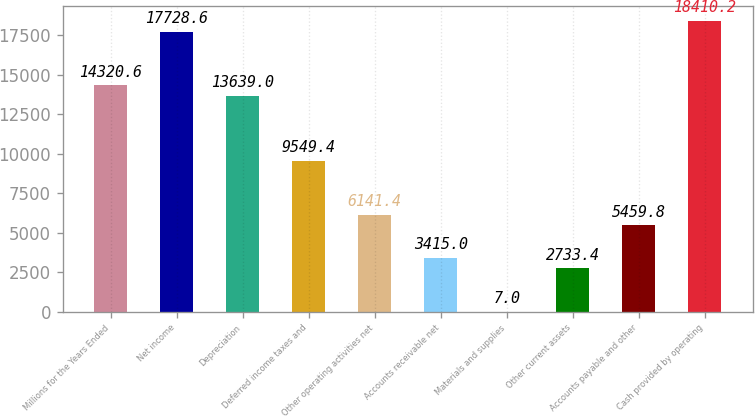<chart> <loc_0><loc_0><loc_500><loc_500><bar_chart><fcel>Millions for the Years Ended<fcel>Net income<fcel>Depreciation<fcel>Deferred income taxes and<fcel>Other operating activities net<fcel>Accounts receivable net<fcel>Materials and supplies<fcel>Other current assets<fcel>Accounts payable and other<fcel>Cash provided by operating<nl><fcel>14320.6<fcel>17728.6<fcel>13639<fcel>9549.4<fcel>6141.4<fcel>3415<fcel>7<fcel>2733.4<fcel>5459.8<fcel>18410.2<nl></chart> 